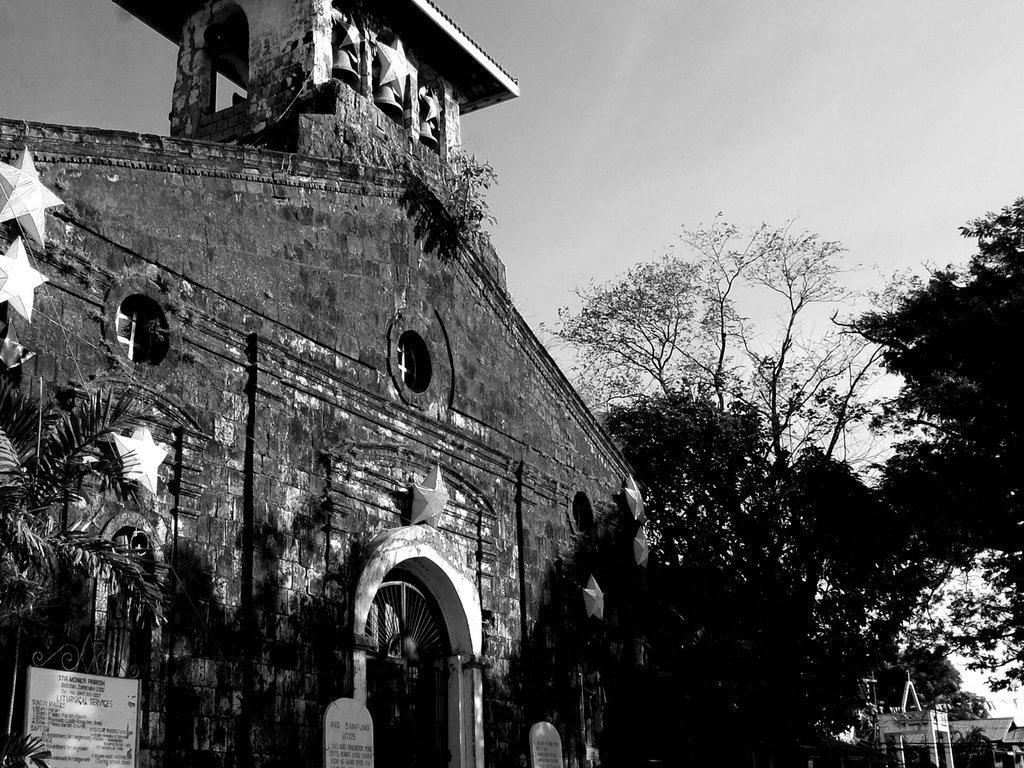In one or two sentences, can you explain what this image depicts? In this black and white picture there is a building. Before it there are few boards, plants and trees. Right side there are few buildings , behind there are few trees. Top of image there is sky. Few stars are attached to the wall. There are three bells hanged to the roof of the wall. 